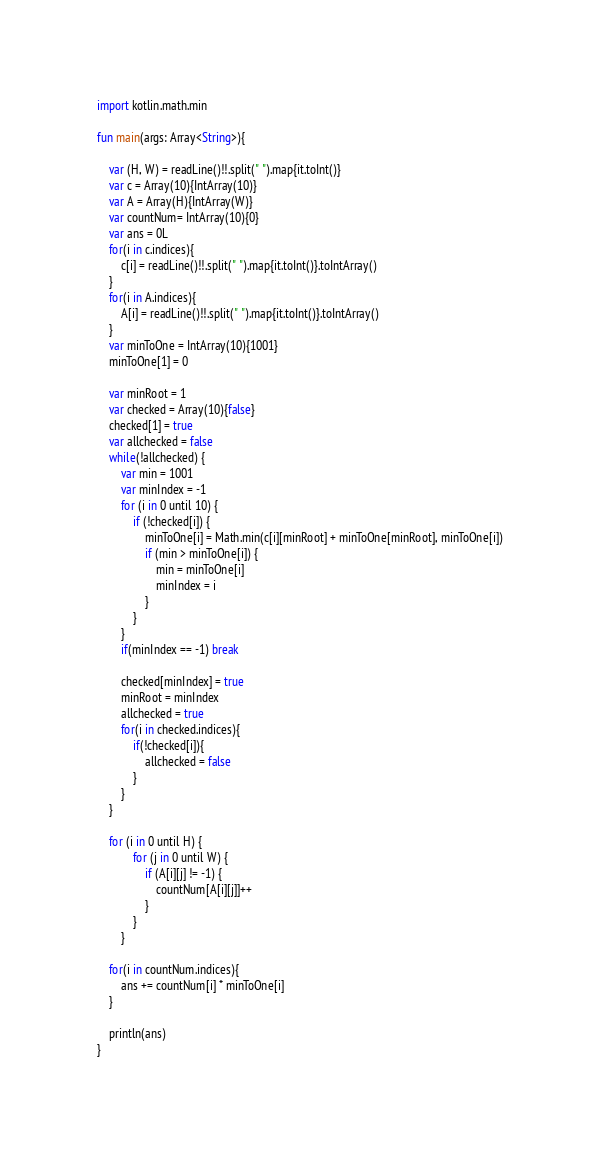<code> <loc_0><loc_0><loc_500><loc_500><_Kotlin_>import kotlin.math.min

fun main(args: Array<String>){

    var (H, W) = readLine()!!.split(" ").map{it.toInt()}
    var c = Array(10){IntArray(10)}
    var A = Array(H){IntArray(W)}
    var countNum= IntArray(10){0}
    var ans = 0L
    for(i in c.indices){
        c[i] = readLine()!!.split(" ").map{it.toInt()}.toIntArray()
    }
    for(i in A.indices){
        A[i] = readLine()!!.split(" ").map{it.toInt()}.toIntArray()
    }
    var minToOne = IntArray(10){1001}
    minToOne[1] = 0

    var minRoot = 1
    var checked = Array(10){false}
    checked[1] = true
    var allchecked = false
    while(!allchecked) {
        var min = 1001
        var minIndex = -1
        for (i in 0 until 10) {
            if (!checked[i]) {
                minToOne[i] = Math.min(c[i][minRoot] + minToOne[minRoot], minToOne[i])
                if (min > minToOne[i]) {
                    min = minToOne[i]
                    minIndex = i
                }
            }
        }
        if(minIndex == -1) break

        checked[minIndex] = true
        minRoot = minIndex
        allchecked = true
        for(i in checked.indices){
            if(!checked[i]){
                allchecked = false
            }
        }
    }

    for (i in 0 until H) {
            for (j in 0 until W) {
                if (A[i][j] != -1) {
                    countNum[A[i][j]]++
                }
            }
        }

    for(i in countNum.indices){
        ans += countNum[i] * minToOne[i]
    }

    println(ans)
}</code> 